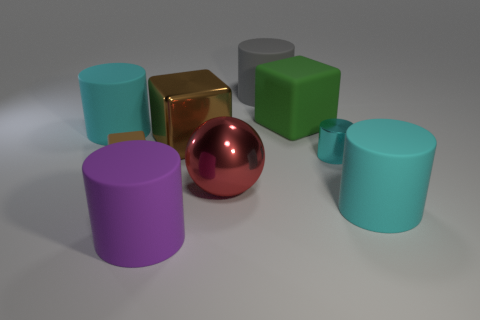Are there an equal number of small rubber things that are right of the large purple rubber thing and tiny green rubber cylinders? yes 